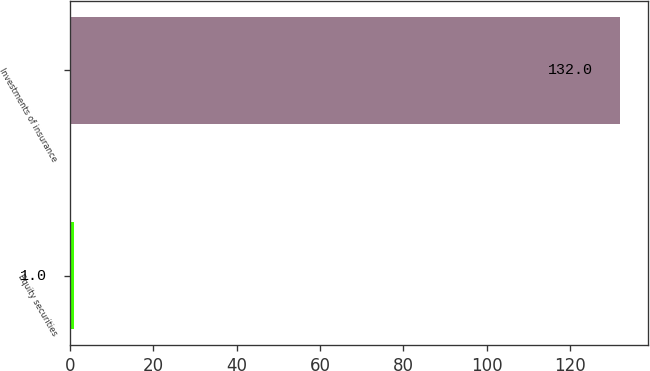Convert chart. <chart><loc_0><loc_0><loc_500><loc_500><bar_chart><fcel>Equity securities<fcel>Investments of insurance<nl><fcel>1<fcel>132<nl></chart> 